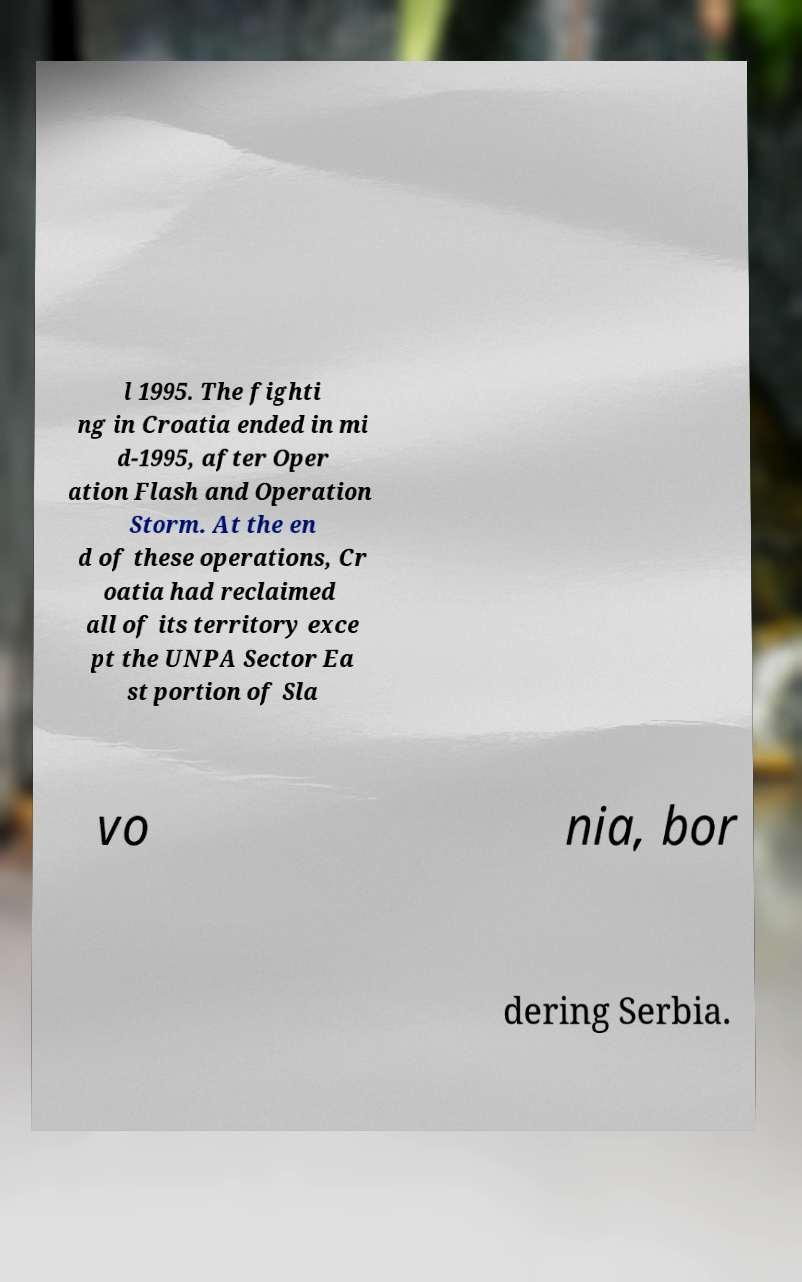I need the written content from this picture converted into text. Can you do that? l 1995. The fighti ng in Croatia ended in mi d-1995, after Oper ation Flash and Operation Storm. At the en d of these operations, Cr oatia had reclaimed all of its territory exce pt the UNPA Sector Ea st portion of Sla vo nia, bor dering Serbia. 